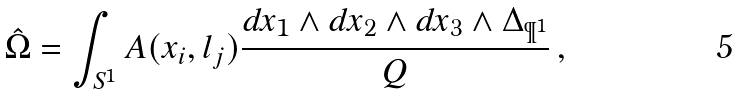<formula> <loc_0><loc_0><loc_500><loc_500>\hat { \Omega } = \int _ { S ^ { 1 } } A ( x _ { i } , l _ { j } ) \frac { d x _ { 1 } \wedge d x _ { 2 } \wedge d x _ { 3 } \wedge \Delta _ { \P ^ { 1 } } } { Q } \, ,</formula> 